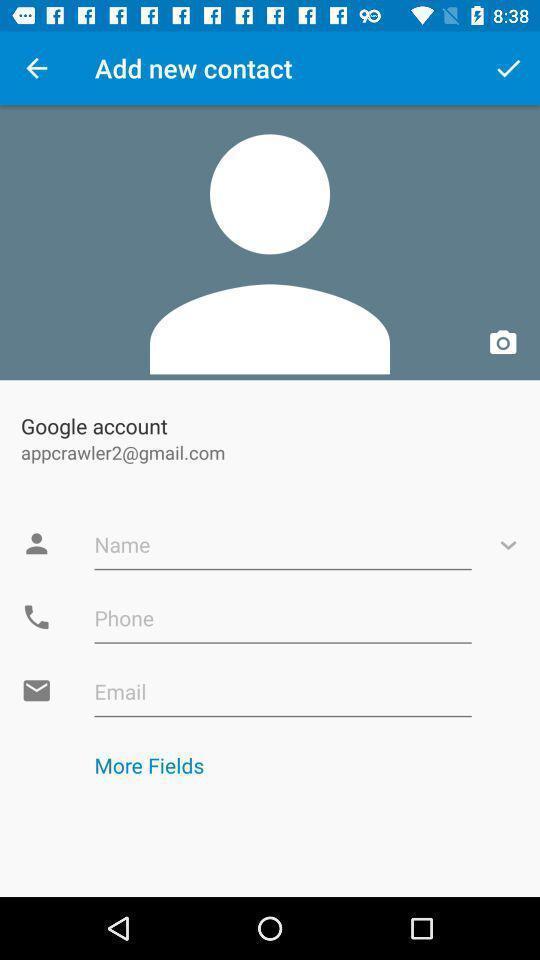Summarize the main components in this picture. Screen displaying create new account page. 